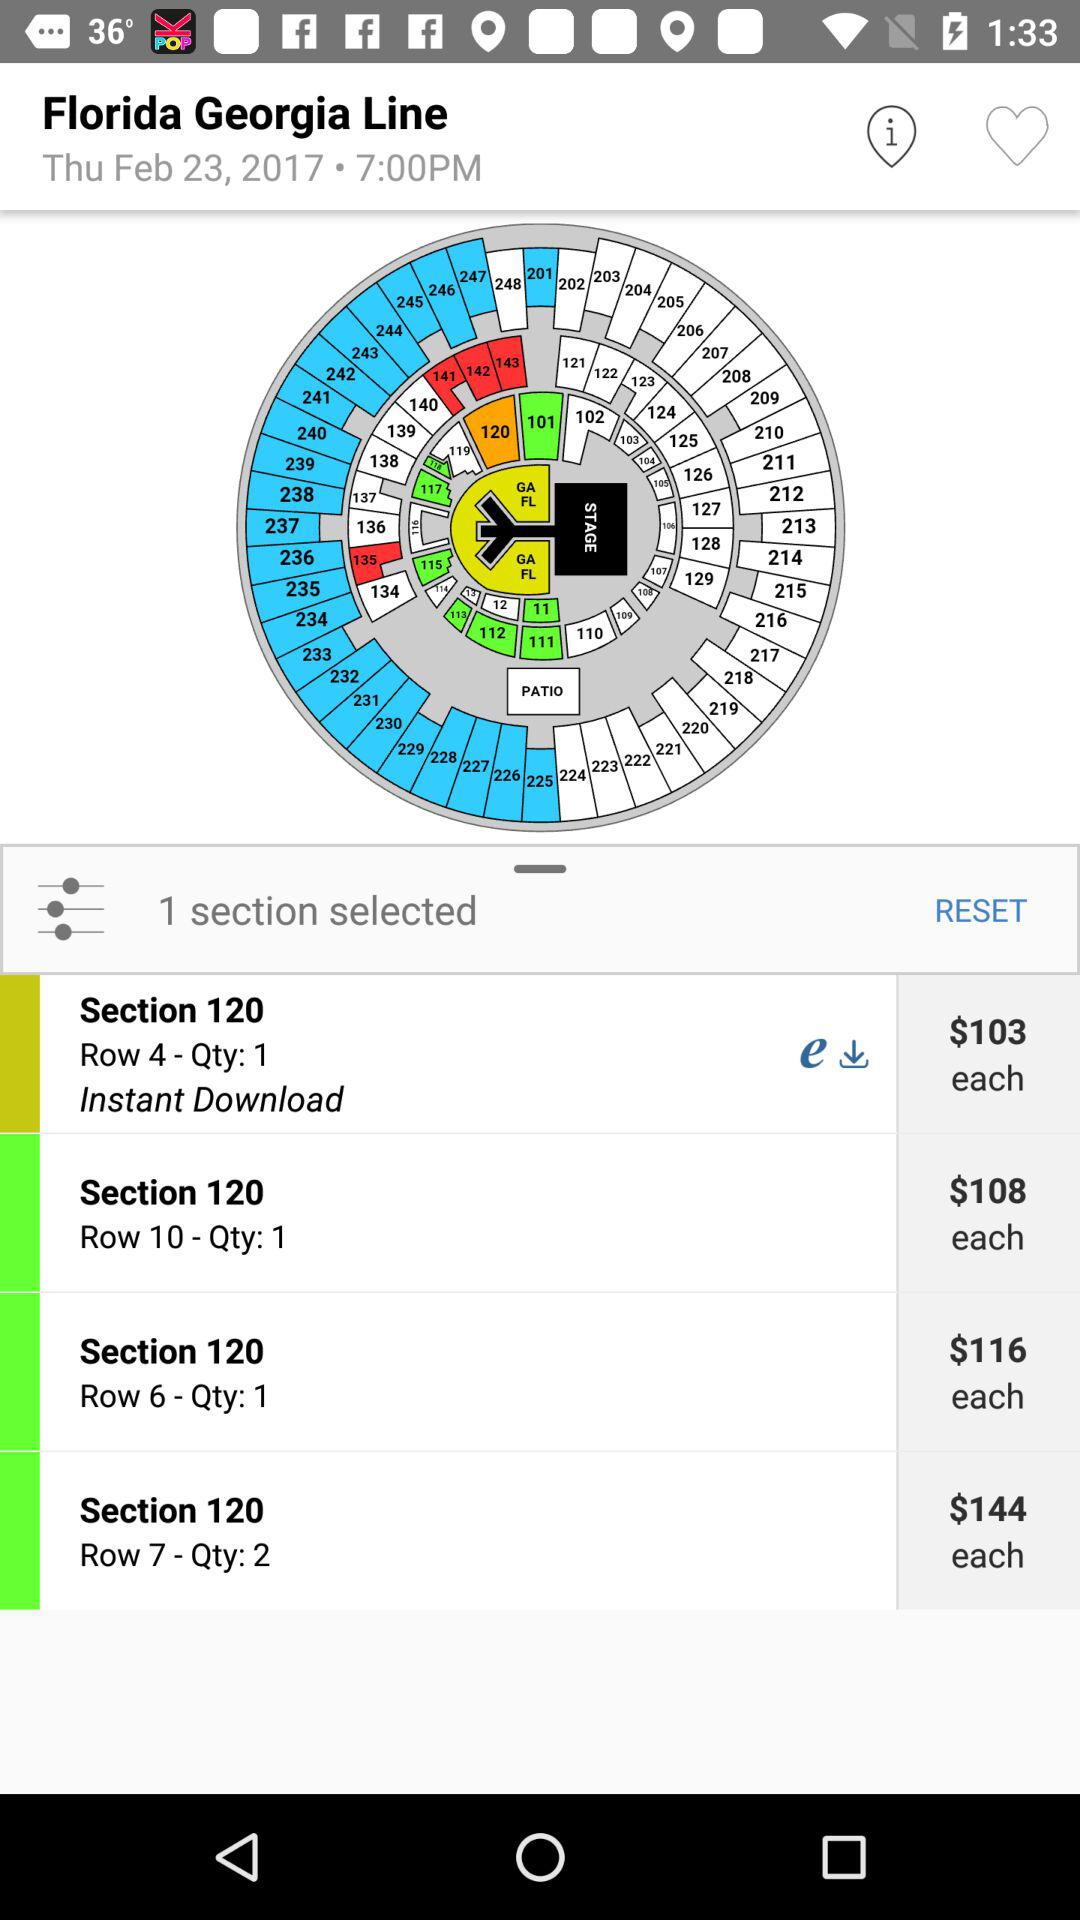What is the mentioned time? The mentioned time is 7:00 PM. 